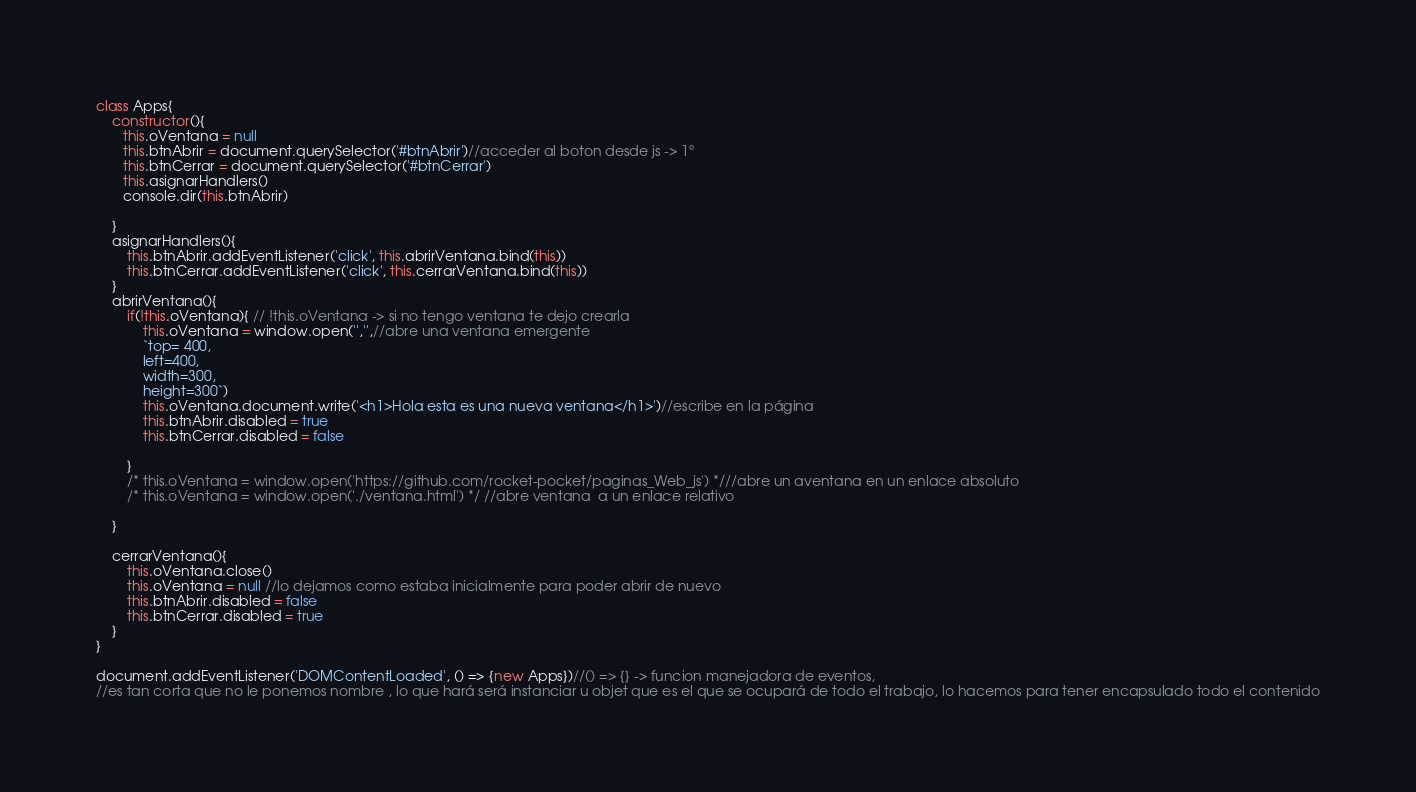Convert code to text. <code><loc_0><loc_0><loc_500><loc_500><_JavaScript_>class Apps{
    constructor(){
       this.oVentana = null
       this.btnAbrir = document.querySelector('#btnAbrir')//acceder al boton desde js -> 1º
       this.btnCerrar = document.querySelector('#btnCerrar')
       this.asignarHandlers()  
       console.dir(this.btnAbrir)    
       
    }
    asignarHandlers(){
        this.btnAbrir.addEventListener('click', this.abrirVentana.bind(this))
        this.btnCerrar.addEventListener('click', this.cerrarVentana.bind(this))
    }
    abrirVentana(){
        if(!this.oVentana){ // !this.oVentana -> si no tengo ventana te dejo crearla 
            this.oVentana = window.open('','',//abre una ventana emergente
            `top= 400,
            left=400,
            width=300,
            height=300`)
            this.oVentana.document.write('<h1>Hola esta es una nueva ventana</h1>')//escribe en la página
            this.btnAbrir.disabled = true
            this.btnCerrar.disabled = false

        }
        /* this.oVentana = window.open('https://github.com/rocket-pocket/paginas_Web_js') *///abre un aventana en un enlace absoluto
        /* this.oVentana = window.open('./ventana.html') */ //abre ventana  a un enlace relativo       
        
    }
    
    cerrarVentana(){
        this.oVentana.close()
        this.oVentana = null //lo dejamos como estaba inicialmente para poder abrir de nuevo
        this.btnAbrir.disabled = false
        this.btnCerrar.disabled = true 
    }
}

document.addEventListener('DOMContentLoaded', () => {new Apps})//() => {} -> funcion manejadora de eventos,
//es tan corta que no le ponemos nombre , lo que hará será instanciar u objet que es el que se ocupará de todo el trabajo, lo hacemos para tener encapsulado todo el contenido</code> 